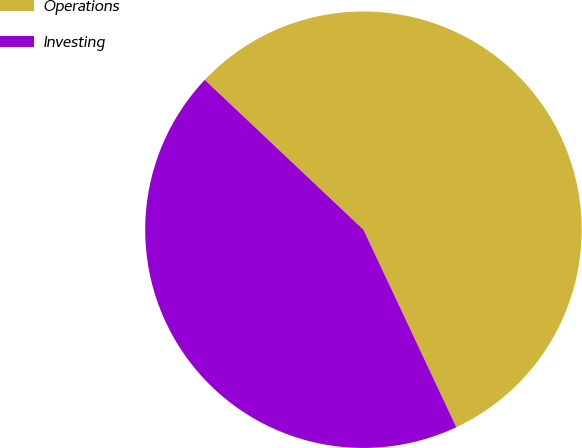Convert chart. <chart><loc_0><loc_0><loc_500><loc_500><pie_chart><fcel>Operations<fcel>Investing<nl><fcel>55.96%<fcel>44.04%<nl></chart> 